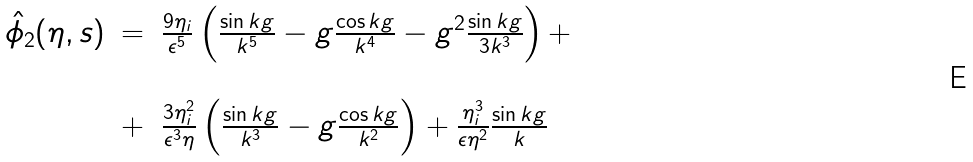Convert formula to latex. <formula><loc_0><loc_0><loc_500><loc_500>\begin{array} { r c l } \hat { \phi } _ { 2 } ( \eta , s ) & = & \frac { 9 \eta _ { i } } { \epsilon ^ { 5 } } \left ( \frac { \sin k g } { k ^ { 5 } } - g \frac { \cos k g } { k ^ { 4 } } - g ^ { 2 } \frac { \sin k g } { 3 k ^ { 3 } } \right ) + \\ \\ & + & \frac { 3 \eta _ { i } ^ { 2 } } { \epsilon ^ { 3 } \eta } \left ( \frac { \sin k g } { k ^ { 3 } } - g \frac { \cos k g } { k ^ { 2 } } \right ) + \frac { \eta _ { i } ^ { 3 } } { \epsilon \eta ^ { 2 } } \frac { \sin k g } { k } \end{array}</formula> 